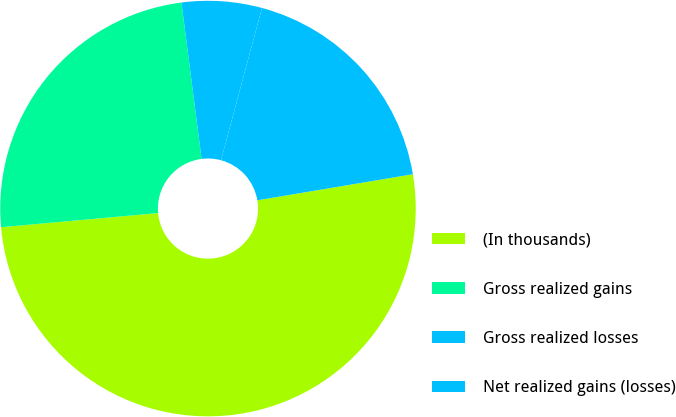<chart> <loc_0><loc_0><loc_500><loc_500><pie_chart><fcel>(In thousands)<fcel>Gross realized gains<fcel>Gross realized losses<fcel>Net realized gains (losses)<nl><fcel>51.21%<fcel>24.39%<fcel>6.22%<fcel>18.17%<nl></chart> 